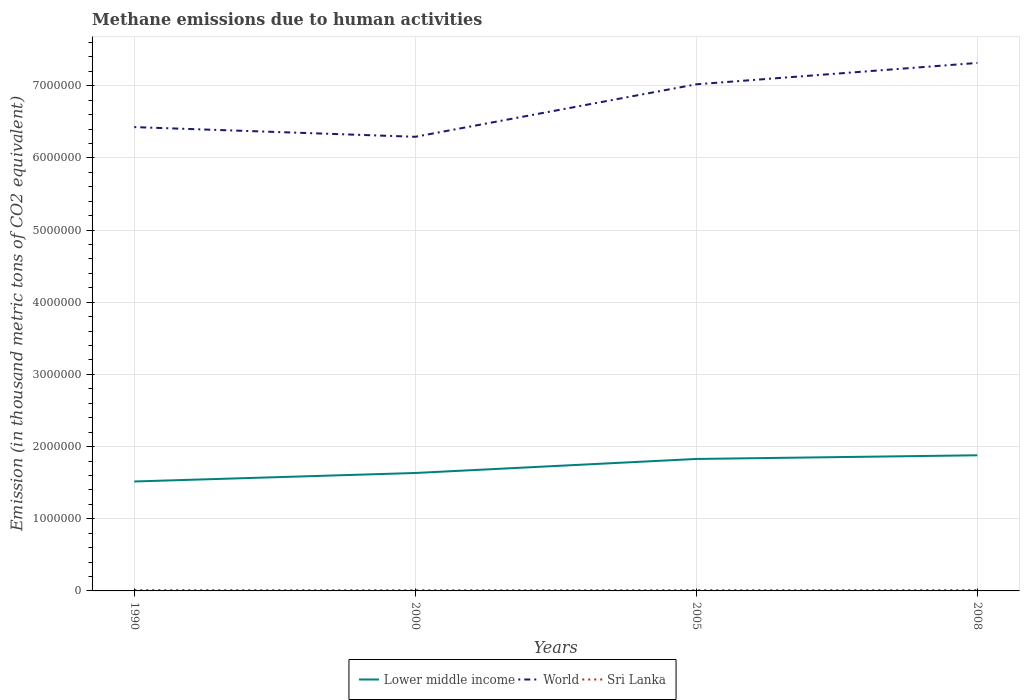Across all years, what is the maximum amount of methane emitted in Lower middle income?
Provide a short and direct response. 1.52e+06. What is the total amount of methane emitted in World in the graph?
Offer a very short reply. -1.02e+06. What is the difference between the highest and the second highest amount of methane emitted in World?
Your answer should be very brief. 1.02e+06. What is the difference between the highest and the lowest amount of methane emitted in Sri Lanka?
Provide a short and direct response. 2. Is the amount of methane emitted in Lower middle income strictly greater than the amount of methane emitted in World over the years?
Your answer should be compact. Yes. How many lines are there?
Your answer should be compact. 3. How many years are there in the graph?
Your answer should be very brief. 4. What is the difference between two consecutive major ticks on the Y-axis?
Make the answer very short. 1.00e+06. Does the graph contain any zero values?
Give a very brief answer. No. Does the graph contain grids?
Ensure brevity in your answer.  Yes. How many legend labels are there?
Your response must be concise. 3. What is the title of the graph?
Offer a very short reply. Methane emissions due to human activities. What is the label or title of the X-axis?
Offer a terse response. Years. What is the label or title of the Y-axis?
Offer a terse response. Emission (in thousand metric tons of CO2 equivalent). What is the Emission (in thousand metric tons of CO2 equivalent) in Lower middle income in 1990?
Give a very brief answer. 1.52e+06. What is the Emission (in thousand metric tons of CO2 equivalent) in World in 1990?
Your answer should be very brief. 6.43e+06. What is the Emission (in thousand metric tons of CO2 equivalent) in Sri Lanka in 1990?
Your answer should be compact. 1.15e+04. What is the Emission (in thousand metric tons of CO2 equivalent) in Lower middle income in 2000?
Make the answer very short. 1.63e+06. What is the Emission (in thousand metric tons of CO2 equivalent) of World in 2000?
Provide a succinct answer. 6.29e+06. What is the Emission (in thousand metric tons of CO2 equivalent) of Sri Lanka in 2000?
Keep it short and to the point. 9607.2. What is the Emission (in thousand metric tons of CO2 equivalent) of Lower middle income in 2005?
Provide a succinct answer. 1.83e+06. What is the Emission (in thousand metric tons of CO2 equivalent) in World in 2005?
Ensure brevity in your answer.  7.02e+06. What is the Emission (in thousand metric tons of CO2 equivalent) in Sri Lanka in 2005?
Offer a terse response. 1.03e+04. What is the Emission (in thousand metric tons of CO2 equivalent) in Lower middle income in 2008?
Provide a succinct answer. 1.88e+06. What is the Emission (in thousand metric tons of CO2 equivalent) in World in 2008?
Offer a terse response. 7.32e+06. What is the Emission (in thousand metric tons of CO2 equivalent) in Sri Lanka in 2008?
Provide a short and direct response. 1.14e+04. Across all years, what is the maximum Emission (in thousand metric tons of CO2 equivalent) of Lower middle income?
Your answer should be compact. 1.88e+06. Across all years, what is the maximum Emission (in thousand metric tons of CO2 equivalent) of World?
Provide a succinct answer. 7.32e+06. Across all years, what is the maximum Emission (in thousand metric tons of CO2 equivalent) of Sri Lanka?
Give a very brief answer. 1.15e+04. Across all years, what is the minimum Emission (in thousand metric tons of CO2 equivalent) in Lower middle income?
Keep it short and to the point. 1.52e+06. Across all years, what is the minimum Emission (in thousand metric tons of CO2 equivalent) in World?
Provide a succinct answer. 6.29e+06. Across all years, what is the minimum Emission (in thousand metric tons of CO2 equivalent) in Sri Lanka?
Offer a terse response. 9607.2. What is the total Emission (in thousand metric tons of CO2 equivalent) of Lower middle income in the graph?
Offer a terse response. 6.86e+06. What is the total Emission (in thousand metric tons of CO2 equivalent) in World in the graph?
Give a very brief answer. 2.71e+07. What is the total Emission (in thousand metric tons of CO2 equivalent) of Sri Lanka in the graph?
Offer a terse response. 4.28e+04. What is the difference between the Emission (in thousand metric tons of CO2 equivalent) of Lower middle income in 1990 and that in 2000?
Give a very brief answer. -1.18e+05. What is the difference between the Emission (in thousand metric tons of CO2 equivalent) in World in 1990 and that in 2000?
Ensure brevity in your answer.  1.34e+05. What is the difference between the Emission (in thousand metric tons of CO2 equivalent) in Sri Lanka in 1990 and that in 2000?
Your answer should be very brief. 1907. What is the difference between the Emission (in thousand metric tons of CO2 equivalent) of Lower middle income in 1990 and that in 2005?
Provide a short and direct response. -3.12e+05. What is the difference between the Emission (in thousand metric tons of CO2 equivalent) in World in 1990 and that in 2005?
Keep it short and to the point. -5.93e+05. What is the difference between the Emission (in thousand metric tons of CO2 equivalent) of Sri Lanka in 1990 and that in 2005?
Your answer should be very brief. 1219.7. What is the difference between the Emission (in thousand metric tons of CO2 equivalent) in Lower middle income in 1990 and that in 2008?
Offer a very short reply. -3.63e+05. What is the difference between the Emission (in thousand metric tons of CO2 equivalent) of World in 1990 and that in 2008?
Your answer should be very brief. -8.89e+05. What is the difference between the Emission (in thousand metric tons of CO2 equivalent) in Sri Lanka in 1990 and that in 2008?
Your answer should be very brief. 161. What is the difference between the Emission (in thousand metric tons of CO2 equivalent) in Lower middle income in 2000 and that in 2005?
Offer a terse response. -1.94e+05. What is the difference between the Emission (in thousand metric tons of CO2 equivalent) of World in 2000 and that in 2005?
Your answer should be compact. -7.27e+05. What is the difference between the Emission (in thousand metric tons of CO2 equivalent) in Sri Lanka in 2000 and that in 2005?
Make the answer very short. -687.3. What is the difference between the Emission (in thousand metric tons of CO2 equivalent) of Lower middle income in 2000 and that in 2008?
Offer a terse response. -2.45e+05. What is the difference between the Emission (in thousand metric tons of CO2 equivalent) of World in 2000 and that in 2008?
Offer a very short reply. -1.02e+06. What is the difference between the Emission (in thousand metric tons of CO2 equivalent) of Sri Lanka in 2000 and that in 2008?
Your answer should be very brief. -1746. What is the difference between the Emission (in thousand metric tons of CO2 equivalent) in Lower middle income in 2005 and that in 2008?
Your answer should be very brief. -5.09e+04. What is the difference between the Emission (in thousand metric tons of CO2 equivalent) in World in 2005 and that in 2008?
Provide a succinct answer. -2.96e+05. What is the difference between the Emission (in thousand metric tons of CO2 equivalent) of Sri Lanka in 2005 and that in 2008?
Keep it short and to the point. -1058.7. What is the difference between the Emission (in thousand metric tons of CO2 equivalent) of Lower middle income in 1990 and the Emission (in thousand metric tons of CO2 equivalent) of World in 2000?
Your answer should be very brief. -4.78e+06. What is the difference between the Emission (in thousand metric tons of CO2 equivalent) in Lower middle income in 1990 and the Emission (in thousand metric tons of CO2 equivalent) in Sri Lanka in 2000?
Offer a very short reply. 1.51e+06. What is the difference between the Emission (in thousand metric tons of CO2 equivalent) in World in 1990 and the Emission (in thousand metric tons of CO2 equivalent) in Sri Lanka in 2000?
Provide a short and direct response. 6.42e+06. What is the difference between the Emission (in thousand metric tons of CO2 equivalent) of Lower middle income in 1990 and the Emission (in thousand metric tons of CO2 equivalent) of World in 2005?
Provide a succinct answer. -5.50e+06. What is the difference between the Emission (in thousand metric tons of CO2 equivalent) in Lower middle income in 1990 and the Emission (in thousand metric tons of CO2 equivalent) in Sri Lanka in 2005?
Provide a short and direct response. 1.51e+06. What is the difference between the Emission (in thousand metric tons of CO2 equivalent) in World in 1990 and the Emission (in thousand metric tons of CO2 equivalent) in Sri Lanka in 2005?
Make the answer very short. 6.42e+06. What is the difference between the Emission (in thousand metric tons of CO2 equivalent) of Lower middle income in 1990 and the Emission (in thousand metric tons of CO2 equivalent) of World in 2008?
Provide a succinct answer. -5.80e+06. What is the difference between the Emission (in thousand metric tons of CO2 equivalent) in Lower middle income in 1990 and the Emission (in thousand metric tons of CO2 equivalent) in Sri Lanka in 2008?
Make the answer very short. 1.51e+06. What is the difference between the Emission (in thousand metric tons of CO2 equivalent) in World in 1990 and the Emission (in thousand metric tons of CO2 equivalent) in Sri Lanka in 2008?
Offer a terse response. 6.42e+06. What is the difference between the Emission (in thousand metric tons of CO2 equivalent) in Lower middle income in 2000 and the Emission (in thousand metric tons of CO2 equivalent) in World in 2005?
Provide a short and direct response. -5.39e+06. What is the difference between the Emission (in thousand metric tons of CO2 equivalent) of Lower middle income in 2000 and the Emission (in thousand metric tons of CO2 equivalent) of Sri Lanka in 2005?
Keep it short and to the point. 1.62e+06. What is the difference between the Emission (in thousand metric tons of CO2 equivalent) of World in 2000 and the Emission (in thousand metric tons of CO2 equivalent) of Sri Lanka in 2005?
Keep it short and to the point. 6.28e+06. What is the difference between the Emission (in thousand metric tons of CO2 equivalent) in Lower middle income in 2000 and the Emission (in thousand metric tons of CO2 equivalent) in World in 2008?
Your response must be concise. -5.68e+06. What is the difference between the Emission (in thousand metric tons of CO2 equivalent) in Lower middle income in 2000 and the Emission (in thousand metric tons of CO2 equivalent) in Sri Lanka in 2008?
Provide a short and direct response. 1.62e+06. What is the difference between the Emission (in thousand metric tons of CO2 equivalent) in World in 2000 and the Emission (in thousand metric tons of CO2 equivalent) in Sri Lanka in 2008?
Keep it short and to the point. 6.28e+06. What is the difference between the Emission (in thousand metric tons of CO2 equivalent) in Lower middle income in 2005 and the Emission (in thousand metric tons of CO2 equivalent) in World in 2008?
Keep it short and to the point. -5.49e+06. What is the difference between the Emission (in thousand metric tons of CO2 equivalent) in Lower middle income in 2005 and the Emission (in thousand metric tons of CO2 equivalent) in Sri Lanka in 2008?
Give a very brief answer. 1.82e+06. What is the difference between the Emission (in thousand metric tons of CO2 equivalent) of World in 2005 and the Emission (in thousand metric tons of CO2 equivalent) of Sri Lanka in 2008?
Provide a succinct answer. 7.01e+06. What is the average Emission (in thousand metric tons of CO2 equivalent) in Lower middle income per year?
Provide a succinct answer. 1.71e+06. What is the average Emission (in thousand metric tons of CO2 equivalent) in World per year?
Your answer should be very brief. 6.76e+06. What is the average Emission (in thousand metric tons of CO2 equivalent) in Sri Lanka per year?
Keep it short and to the point. 1.07e+04. In the year 1990, what is the difference between the Emission (in thousand metric tons of CO2 equivalent) in Lower middle income and Emission (in thousand metric tons of CO2 equivalent) in World?
Your answer should be very brief. -4.91e+06. In the year 1990, what is the difference between the Emission (in thousand metric tons of CO2 equivalent) of Lower middle income and Emission (in thousand metric tons of CO2 equivalent) of Sri Lanka?
Provide a succinct answer. 1.50e+06. In the year 1990, what is the difference between the Emission (in thousand metric tons of CO2 equivalent) of World and Emission (in thousand metric tons of CO2 equivalent) of Sri Lanka?
Your answer should be very brief. 6.42e+06. In the year 2000, what is the difference between the Emission (in thousand metric tons of CO2 equivalent) of Lower middle income and Emission (in thousand metric tons of CO2 equivalent) of World?
Offer a terse response. -4.66e+06. In the year 2000, what is the difference between the Emission (in thousand metric tons of CO2 equivalent) of Lower middle income and Emission (in thousand metric tons of CO2 equivalent) of Sri Lanka?
Offer a very short reply. 1.62e+06. In the year 2000, what is the difference between the Emission (in thousand metric tons of CO2 equivalent) in World and Emission (in thousand metric tons of CO2 equivalent) in Sri Lanka?
Your answer should be compact. 6.28e+06. In the year 2005, what is the difference between the Emission (in thousand metric tons of CO2 equivalent) in Lower middle income and Emission (in thousand metric tons of CO2 equivalent) in World?
Provide a succinct answer. -5.19e+06. In the year 2005, what is the difference between the Emission (in thousand metric tons of CO2 equivalent) of Lower middle income and Emission (in thousand metric tons of CO2 equivalent) of Sri Lanka?
Provide a short and direct response. 1.82e+06. In the year 2005, what is the difference between the Emission (in thousand metric tons of CO2 equivalent) of World and Emission (in thousand metric tons of CO2 equivalent) of Sri Lanka?
Your answer should be very brief. 7.01e+06. In the year 2008, what is the difference between the Emission (in thousand metric tons of CO2 equivalent) of Lower middle income and Emission (in thousand metric tons of CO2 equivalent) of World?
Ensure brevity in your answer.  -5.44e+06. In the year 2008, what is the difference between the Emission (in thousand metric tons of CO2 equivalent) of Lower middle income and Emission (in thousand metric tons of CO2 equivalent) of Sri Lanka?
Your response must be concise. 1.87e+06. In the year 2008, what is the difference between the Emission (in thousand metric tons of CO2 equivalent) of World and Emission (in thousand metric tons of CO2 equivalent) of Sri Lanka?
Your response must be concise. 7.30e+06. What is the ratio of the Emission (in thousand metric tons of CO2 equivalent) of Lower middle income in 1990 to that in 2000?
Make the answer very short. 0.93. What is the ratio of the Emission (in thousand metric tons of CO2 equivalent) of World in 1990 to that in 2000?
Give a very brief answer. 1.02. What is the ratio of the Emission (in thousand metric tons of CO2 equivalent) in Sri Lanka in 1990 to that in 2000?
Your answer should be very brief. 1.2. What is the ratio of the Emission (in thousand metric tons of CO2 equivalent) of Lower middle income in 1990 to that in 2005?
Keep it short and to the point. 0.83. What is the ratio of the Emission (in thousand metric tons of CO2 equivalent) in World in 1990 to that in 2005?
Offer a terse response. 0.92. What is the ratio of the Emission (in thousand metric tons of CO2 equivalent) in Sri Lanka in 1990 to that in 2005?
Your answer should be very brief. 1.12. What is the ratio of the Emission (in thousand metric tons of CO2 equivalent) of Lower middle income in 1990 to that in 2008?
Ensure brevity in your answer.  0.81. What is the ratio of the Emission (in thousand metric tons of CO2 equivalent) in World in 1990 to that in 2008?
Your response must be concise. 0.88. What is the ratio of the Emission (in thousand metric tons of CO2 equivalent) in Sri Lanka in 1990 to that in 2008?
Keep it short and to the point. 1.01. What is the ratio of the Emission (in thousand metric tons of CO2 equivalent) of Lower middle income in 2000 to that in 2005?
Your response must be concise. 0.89. What is the ratio of the Emission (in thousand metric tons of CO2 equivalent) in World in 2000 to that in 2005?
Offer a very short reply. 0.9. What is the ratio of the Emission (in thousand metric tons of CO2 equivalent) of Sri Lanka in 2000 to that in 2005?
Give a very brief answer. 0.93. What is the ratio of the Emission (in thousand metric tons of CO2 equivalent) in Lower middle income in 2000 to that in 2008?
Offer a terse response. 0.87. What is the ratio of the Emission (in thousand metric tons of CO2 equivalent) in World in 2000 to that in 2008?
Ensure brevity in your answer.  0.86. What is the ratio of the Emission (in thousand metric tons of CO2 equivalent) in Sri Lanka in 2000 to that in 2008?
Your answer should be compact. 0.85. What is the ratio of the Emission (in thousand metric tons of CO2 equivalent) of Lower middle income in 2005 to that in 2008?
Provide a succinct answer. 0.97. What is the ratio of the Emission (in thousand metric tons of CO2 equivalent) of World in 2005 to that in 2008?
Your answer should be very brief. 0.96. What is the ratio of the Emission (in thousand metric tons of CO2 equivalent) in Sri Lanka in 2005 to that in 2008?
Provide a short and direct response. 0.91. What is the difference between the highest and the second highest Emission (in thousand metric tons of CO2 equivalent) of Lower middle income?
Offer a very short reply. 5.09e+04. What is the difference between the highest and the second highest Emission (in thousand metric tons of CO2 equivalent) in World?
Provide a short and direct response. 2.96e+05. What is the difference between the highest and the second highest Emission (in thousand metric tons of CO2 equivalent) of Sri Lanka?
Ensure brevity in your answer.  161. What is the difference between the highest and the lowest Emission (in thousand metric tons of CO2 equivalent) of Lower middle income?
Your answer should be compact. 3.63e+05. What is the difference between the highest and the lowest Emission (in thousand metric tons of CO2 equivalent) of World?
Give a very brief answer. 1.02e+06. What is the difference between the highest and the lowest Emission (in thousand metric tons of CO2 equivalent) of Sri Lanka?
Your response must be concise. 1907. 